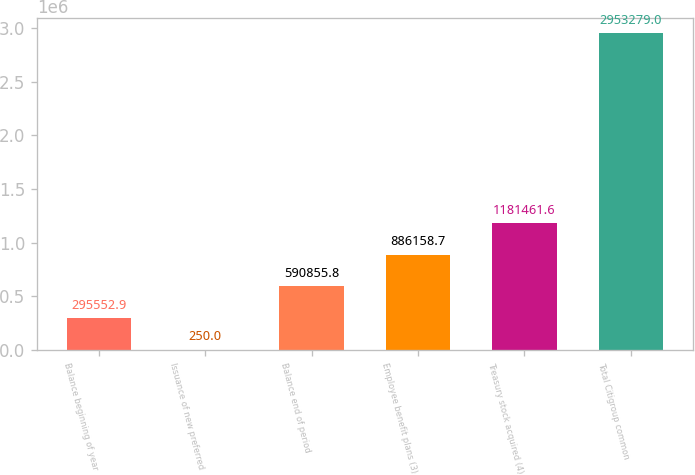Convert chart to OTSL. <chart><loc_0><loc_0><loc_500><loc_500><bar_chart><fcel>Balance beginning of year<fcel>Issuance of new preferred<fcel>Balance end of period<fcel>Employee benefit plans (3)<fcel>Treasury stock acquired (4)<fcel>Total Citigroup common<nl><fcel>295553<fcel>250<fcel>590856<fcel>886159<fcel>1.18146e+06<fcel>2.95328e+06<nl></chart> 